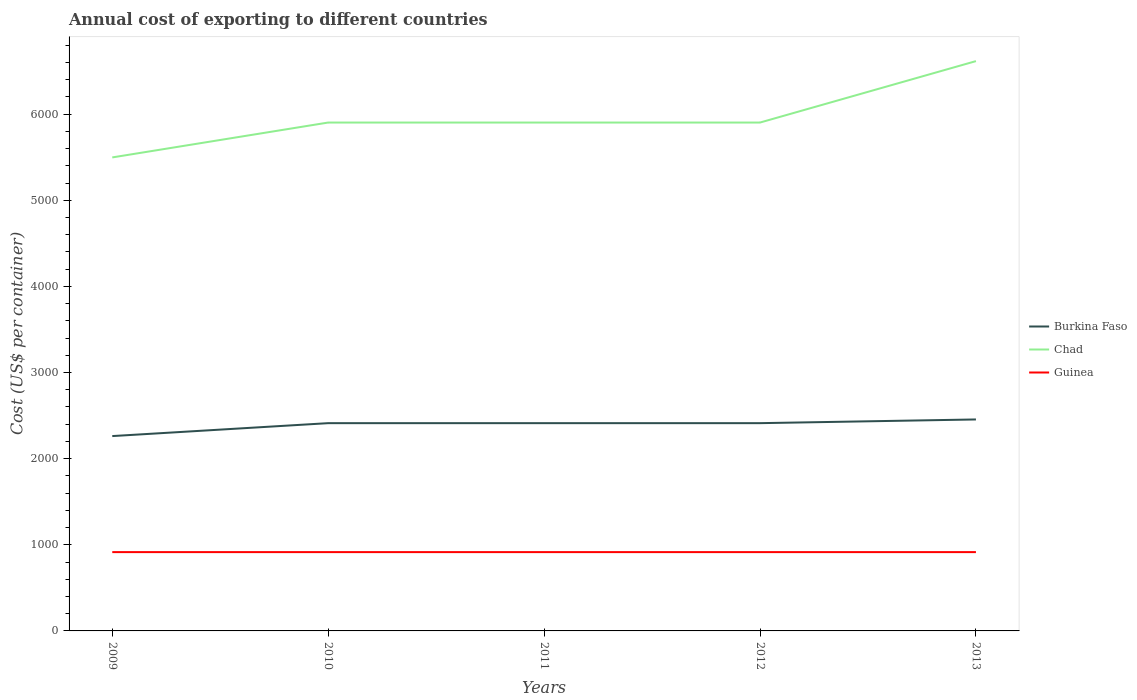How many different coloured lines are there?
Your answer should be compact. 3. Across all years, what is the maximum total annual cost of exporting in Burkina Faso?
Offer a terse response. 2262. What is the total total annual cost of exporting in Chad in the graph?
Give a very brief answer. -713. What is the difference between the highest and the second highest total annual cost of exporting in Burkina Faso?
Offer a terse response. 193. What is the difference between the highest and the lowest total annual cost of exporting in Guinea?
Provide a succinct answer. 0. How many years are there in the graph?
Provide a short and direct response. 5. What is the difference between two consecutive major ticks on the Y-axis?
Give a very brief answer. 1000. Does the graph contain any zero values?
Make the answer very short. No. Does the graph contain grids?
Offer a very short reply. No. What is the title of the graph?
Offer a terse response. Annual cost of exporting to different countries. What is the label or title of the X-axis?
Your answer should be very brief. Years. What is the label or title of the Y-axis?
Give a very brief answer. Cost (US$ per container). What is the Cost (US$ per container) of Burkina Faso in 2009?
Provide a short and direct response. 2262. What is the Cost (US$ per container) of Chad in 2009?
Give a very brief answer. 5497. What is the Cost (US$ per container) of Guinea in 2009?
Make the answer very short. 915. What is the Cost (US$ per container) in Burkina Faso in 2010?
Your answer should be compact. 2412. What is the Cost (US$ per container) in Chad in 2010?
Offer a very short reply. 5902. What is the Cost (US$ per container) of Guinea in 2010?
Make the answer very short. 915. What is the Cost (US$ per container) in Burkina Faso in 2011?
Offer a terse response. 2412. What is the Cost (US$ per container) of Chad in 2011?
Give a very brief answer. 5902. What is the Cost (US$ per container) in Guinea in 2011?
Give a very brief answer. 915. What is the Cost (US$ per container) in Burkina Faso in 2012?
Your answer should be compact. 2412. What is the Cost (US$ per container) in Chad in 2012?
Offer a very short reply. 5902. What is the Cost (US$ per container) in Guinea in 2012?
Offer a terse response. 915. What is the Cost (US$ per container) in Burkina Faso in 2013?
Ensure brevity in your answer.  2455. What is the Cost (US$ per container) of Chad in 2013?
Provide a succinct answer. 6615. What is the Cost (US$ per container) of Guinea in 2013?
Ensure brevity in your answer.  915. Across all years, what is the maximum Cost (US$ per container) of Burkina Faso?
Your response must be concise. 2455. Across all years, what is the maximum Cost (US$ per container) of Chad?
Ensure brevity in your answer.  6615. Across all years, what is the maximum Cost (US$ per container) in Guinea?
Your response must be concise. 915. Across all years, what is the minimum Cost (US$ per container) of Burkina Faso?
Offer a very short reply. 2262. Across all years, what is the minimum Cost (US$ per container) of Chad?
Give a very brief answer. 5497. Across all years, what is the minimum Cost (US$ per container) in Guinea?
Provide a succinct answer. 915. What is the total Cost (US$ per container) in Burkina Faso in the graph?
Offer a terse response. 1.20e+04. What is the total Cost (US$ per container) of Chad in the graph?
Keep it short and to the point. 2.98e+04. What is the total Cost (US$ per container) of Guinea in the graph?
Make the answer very short. 4575. What is the difference between the Cost (US$ per container) of Burkina Faso in 2009 and that in 2010?
Provide a short and direct response. -150. What is the difference between the Cost (US$ per container) of Chad in 2009 and that in 2010?
Keep it short and to the point. -405. What is the difference between the Cost (US$ per container) in Guinea in 2009 and that in 2010?
Keep it short and to the point. 0. What is the difference between the Cost (US$ per container) in Burkina Faso in 2009 and that in 2011?
Make the answer very short. -150. What is the difference between the Cost (US$ per container) of Chad in 2009 and that in 2011?
Your answer should be very brief. -405. What is the difference between the Cost (US$ per container) of Guinea in 2009 and that in 2011?
Keep it short and to the point. 0. What is the difference between the Cost (US$ per container) of Burkina Faso in 2009 and that in 2012?
Provide a succinct answer. -150. What is the difference between the Cost (US$ per container) in Chad in 2009 and that in 2012?
Your answer should be compact. -405. What is the difference between the Cost (US$ per container) in Burkina Faso in 2009 and that in 2013?
Give a very brief answer. -193. What is the difference between the Cost (US$ per container) in Chad in 2009 and that in 2013?
Offer a terse response. -1118. What is the difference between the Cost (US$ per container) in Burkina Faso in 2010 and that in 2011?
Your answer should be compact. 0. What is the difference between the Cost (US$ per container) in Chad in 2010 and that in 2011?
Keep it short and to the point. 0. What is the difference between the Cost (US$ per container) in Guinea in 2010 and that in 2012?
Provide a short and direct response. 0. What is the difference between the Cost (US$ per container) in Burkina Faso in 2010 and that in 2013?
Provide a short and direct response. -43. What is the difference between the Cost (US$ per container) in Chad in 2010 and that in 2013?
Provide a succinct answer. -713. What is the difference between the Cost (US$ per container) in Guinea in 2010 and that in 2013?
Ensure brevity in your answer.  0. What is the difference between the Cost (US$ per container) in Guinea in 2011 and that in 2012?
Your response must be concise. 0. What is the difference between the Cost (US$ per container) in Burkina Faso in 2011 and that in 2013?
Your answer should be compact. -43. What is the difference between the Cost (US$ per container) of Chad in 2011 and that in 2013?
Your response must be concise. -713. What is the difference between the Cost (US$ per container) of Guinea in 2011 and that in 2013?
Your answer should be very brief. 0. What is the difference between the Cost (US$ per container) in Burkina Faso in 2012 and that in 2013?
Provide a succinct answer. -43. What is the difference between the Cost (US$ per container) of Chad in 2012 and that in 2013?
Your response must be concise. -713. What is the difference between the Cost (US$ per container) in Guinea in 2012 and that in 2013?
Give a very brief answer. 0. What is the difference between the Cost (US$ per container) in Burkina Faso in 2009 and the Cost (US$ per container) in Chad in 2010?
Give a very brief answer. -3640. What is the difference between the Cost (US$ per container) in Burkina Faso in 2009 and the Cost (US$ per container) in Guinea in 2010?
Keep it short and to the point. 1347. What is the difference between the Cost (US$ per container) in Chad in 2009 and the Cost (US$ per container) in Guinea in 2010?
Make the answer very short. 4582. What is the difference between the Cost (US$ per container) in Burkina Faso in 2009 and the Cost (US$ per container) in Chad in 2011?
Your response must be concise. -3640. What is the difference between the Cost (US$ per container) of Burkina Faso in 2009 and the Cost (US$ per container) of Guinea in 2011?
Your answer should be very brief. 1347. What is the difference between the Cost (US$ per container) of Chad in 2009 and the Cost (US$ per container) of Guinea in 2011?
Your response must be concise. 4582. What is the difference between the Cost (US$ per container) of Burkina Faso in 2009 and the Cost (US$ per container) of Chad in 2012?
Ensure brevity in your answer.  -3640. What is the difference between the Cost (US$ per container) of Burkina Faso in 2009 and the Cost (US$ per container) of Guinea in 2012?
Give a very brief answer. 1347. What is the difference between the Cost (US$ per container) of Chad in 2009 and the Cost (US$ per container) of Guinea in 2012?
Provide a succinct answer. 4582. What is the difference between the Cost (US$ per container) of Burkina Faso in 2009 and the Cost (US$ per container) of Chad in 2013?
Make the answer very short. -4353. What is the difference between the Cost (US$ per container) in Burkina Faso in 2009 and the Cost (US$ per container) in Guinea in 2013?
Ensure brevity in your answer.  1347. What is the difference between the Cost (US$ per container) of Chad in 2009 and the Cost (US$ per container) of Guinea in 2013?
Give a very brief answer. 4582. What is the difference between the Cost (US$ per container) in Burkina Faso in 2010 and the Cost (US$ per container) in Chad in 2011?
Offer a terse response. -3490. What is the difference between the Cost (US$ per container) of Burkina Faso in 2010 and the Cost (US$ per container) of Guinea in 2011?
Your answer should be very brief. 1497. What is the difference between the Cost (US$ per container) in Chad in 2010 and the Cost (US$ per container) in Guinea in 2011?
Offer a terse response. 4987. What is the difference between the Cost (US$ per container) of Burkina Faso in 2010 and the Cost (US$ per container) of Chad in 2012?
Give a very brief answer. -3490. What is the difference between the Cost (US$ per container) of Burkina Faso in 2010 and the Cost (US$ per container) of Guinea in 2012?
Keep it short and to the point. 1497. What is the difference between the Cost (US$ per container) of Chad in 2010 and the Cost (US$ per container) of Guinea in 2012?
Ensure brevity in your answer.  4987. What is the difference between the Cost (US$ per container) of Burkina Faso in 2010 and the Cost (US$ per container) of Chad in 2013?
Your answer should be compact. -4203. What is the difference between the Cost (US$ per container) in Burkina Faso in 2010 and the Cost (US$ per container) in Guinea in 2013?
Make the answer very short. 1497. What is the difference between the Cost (US$ per container) in Chad in 2010 and the Cost (US$ per container) in Guinea in 2013?
Offer a terse response. 4987. What is the difference between the Cost (US$ per container) in Burkina Faso in 2011 and the Cost (US$ per container) in Chad in 2012?
Offer a terse response. -3490. What is the difference between the Cost (US$ per container) in Burkina Faso in 2011 and the Cost (US$ per container) in Guinea in 2012?
Your response must be concise. 1497. What is the difference between the Cost (US$ per container) in Chad in 2011 and the Cost (US$ per container) in Guinea in 2012?
Your answer should be very brief. 4987. What is the difference between the Cost (US$ per container) of Burkina Faso in 2011 and the Cost (US$ per container) of Chad in 2013?
Offer a very short reply. -4203. What is the difference between the Cost (US$ per container) in Burkina Faso in 2011 and the Cost (US$ per container) in Guinea in 2013?
Your response must be concise. 1497. What is the difference between the Cost (US$ per container) in Chad in 2011 and the Cost (US$ per container) in Guinea in 2013?
Make the answer very short. 4987. What is the difference between the Cost (US$ per container) in Burkina Faso in 2012 and the Cost (US$ per container) in Chad in 2013?
Ensure brevity in your answer.  -4203. What is the difference between the Cost (US$ per container) of Burkina Faso in 2012 and the Cost (US$ per container) of Guinea in 2013?
Make the answer very short. 1497. What is the difference between the Cost (US$ per container) of Chad in 2012 and the Cost (US$ per container) of Guinea in 2013?
Your answer should be compact. 4987. What is the average Cost (US$ per container) in Burkina Faso per year?
Keep it short and to the point. 2390.6. What is the average Cost (US$ per container) in Chad per year?
Provide a succinct answer. 5963.6. What is the average Cost (US$ per container) in Guinea per year?
Make the answer very short. 915. In the year 2009, what is the difference between the Cost (US$ per container) of Burkina Faso and Cost (US$ per container) of Chad?
Your response must be concise. -3235. In the year 2009, what is the difference between the Cost (US$ per container) of Burkina Faso and Cost (US$ per container) of Guinea?
Keep it short and to the point. 1347. In the year 2009, what is the difference between the Cost (US$ per container) in Chad and Cost (US$ per container) in Guinea?
Offer a terse response. 4582. In the year 2010, what is the difference between the Cost (US$ per container) in Burkina Faso and Cost (US$ per container) in Chad?
Make the answer very short. -3490. In the year 2010, what is the difference between the Cost (US$ per container) of Burkina Faso and Cost (US$ per container) of Guinea?
Offer a terse response. 1497. In the year 2010, what is the difference between the Cost (US$ per container) of Chad and Cost (US$ per container) of Guinea?
Your answer should be compact. 4987. In the year 2011, what is the difference between the Cost (US$ per container) of Burkina Faso and Cost (US$ per container) of Chad?
Your answer should be compact. -3490. In the year 2011, what is the difference between the Cost (US$ per container) of Burkina Faso and Cost (US$ per container) of Guinea?
Your response must be concise. 1497. In the year 2011, what is the difference between the Cost (US$ per container) in Chad and Cost (US$ per container) in Guinea?
Keep it short and to the point. 4987. In the year 2012, what is the difference between the Cost (US$ per container) of Burkina Faso and Cost (US$ per container) of Chad?
Make the answer very short. -3490. In the year 2012, what is the difference between the Cost (US$ per container) in Burkina Faso and Cost (US$ per container) in Guinea?
Offer a terse response. 1497. In the year 2012, what is the difference between the Cost (US$ per container) in Chad and Cost (US$ per container) in Guinea?
Your response must be concise. 4987. In the year 2013, what is the difference between the Cost (US$ per container) of Burkina Faso and Cost (US$ per container) of Chad?
Your response must be concise. -4160. In the year 2013, what is the difference between the Cost (US$ per container) of Burkina Faso and Cost (US$ per container) of Guinea?
Ensure brevity in your answer.  1540. In the year 2013, what is the difference between the Cost (US$ per container) of Chad and Cost (US$ per container) of Guinea?
Offer a terse response. 5700. What is the ratio of the Cost (US$ per container) of Burkina Faso in 2009 to that in 2010?
Keep it short and to the point. 0.94. What is the ratio of the Cost (US$ per container) in Chad in 2009 to that in 2010?
Make the answer very short. 0.93. What is the ratio of the Cost (US$ per container) of Guinea in 2009 to that in 2010?
Ensure brevity in your answer.  1. What is the ratio of the Cost (US$ per container) in Burkina Faso in 2009 to that in 2011?
Offer a terse response. 0.94. What is the ratio of the Cost (US$ per container) in Chad in 2009 to that in 2011?
Keep it short and to the point. 0.93. What is the ratio of the Cost (US$ per container) in Guinea in 2009 to that in 2011?
Offer a terse response. 1. What is the ratio of the Cost (US$ per container) in Burkina Faso in 2009 to that in 2012?
Give a very brief answer. 0.94. What is the ratio of the Cost (US$ per container) of Chad in 2009 to that in 2012?
Your answer should be compact. 0.93. What is the ratio of the Cost (US$ per container) in Guinea in 2009 to that in 2012?
Your response must be concise. 1. What is the ratio of the Cost (US$ per container) in Burkina Faso in 2009 to that in 2013?
Offer a very short reply. 0.92. What is the ratio of the Cost (US$ per container) of Chad in 2009 to that in 2013?
Your answer should be compact. 0.83. What is the ratio of the Cost (US$ per container) of Chad in 2010 to that in 2011?
Ensure brevity in your answer.  1. What is the ratio of the Cost (US$ per container) of Burkina Faso in 2010 to that in 2013?
Your answer should be compact. 0.98. What is the ratio of the Cost (US$ per container) in Chad in 2010 to that in 2013?
Your response must be concise. 0.89. What is the ratio of the Cost (US$ per container) of Burkina Faso in 2011 to that in 2012?
Make the answer very short. 1. What is the ratio of the Cost (US$ per container) of Chad in 2011 to that in 2012?
Provide a short and direct response. 1. What is the ratio of the Cost (US$ per container) of Guinea in 2011 to that in 2012?
Make the answer very short. 1. What is the ratio of the Cost (US$ per container) of Burkina Faso in 2011 to that in 2013?
Your response must be concise. 0.98. What is the ratio of the Cost (US$ per container) in Chad in 2011 to that in 2013?
Keep it short and to the point. 0.89. What is the ratio of the Cost (US$ per container) in Guinea in 2011 to that in 2013?
Offer a very short reply. 1. What is the ratio of the Cost (US$ per container) in Burkina Faso in 2012 to that in 2013?
Ensure brevity in your answer.  0.98. What is the ratio of the Cost (US$ per container) in Chad in 2012 to that in 2013?
Provide a succinct answer. 0.89. What is the difference between the highest and the second highest Cost (US$ per container) in Burkina Faso?
Offer a terse response. 43. What is the difference between the highest and the second highest Cost (US$ per container) in Chad?
Provide a short and direct response. 713. What is the difference between the highest and the second highest Cost (US$ per container) in Guinea?
Your response must be concise. 0. What is the difference between the highest and the lowest Cost (US$ per container) of Burkina Faso?
Ensure brevity in your answer.  193. What is the difference between the highest and the lowest Cost (US$ per container) of Chad?
Provide a succinct answer. 1118. 